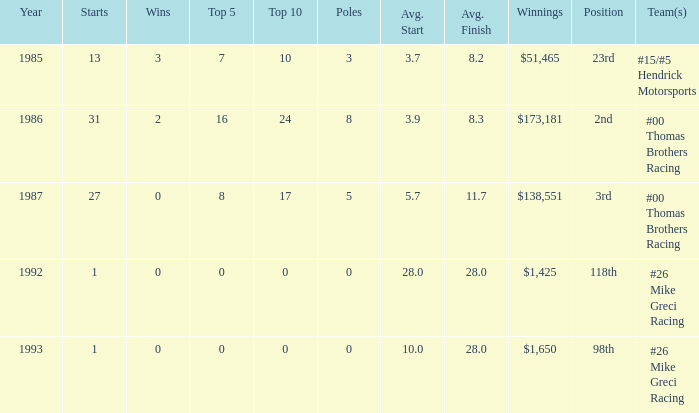How many years did he have an average finish of 11.7? 1.0. Could you parse the entire table as a dict? {'header': ['Year', 'Starts', 'Wins', 'Top 5', 'Top 10', 'Poles', 'Avg. Start', 'Avg. Finish', 'Winnings', 'Position', 'Team(s)'], 'rows': [['1985', '13', '3', '7', '10', '3', '3.7', '8.2', '$51,465', '23rd', '#15/#5 Hendrick Motorsports'], ['1986', '31', '2', '16', '24', '8', '3.9', '8.3', '$173,181', '2nd', '#00 Thomas Brothers Racing'], ['1987', '27', '0', '8', '17', '5', '5.7', '11.7', '$138,551', '3rd', '#00 Thomas Brothers Racing'], ['1992', '1', '0', '0', '0', '0', '28.0', '28.0', '$1,425', '118th', '#26 Mike Greci Racing'], ['1993', '1', '0', '0', '0', '0', '10.0', '28.0', '$1,650', '98th', '#26 Mike Greci Racing']]} 